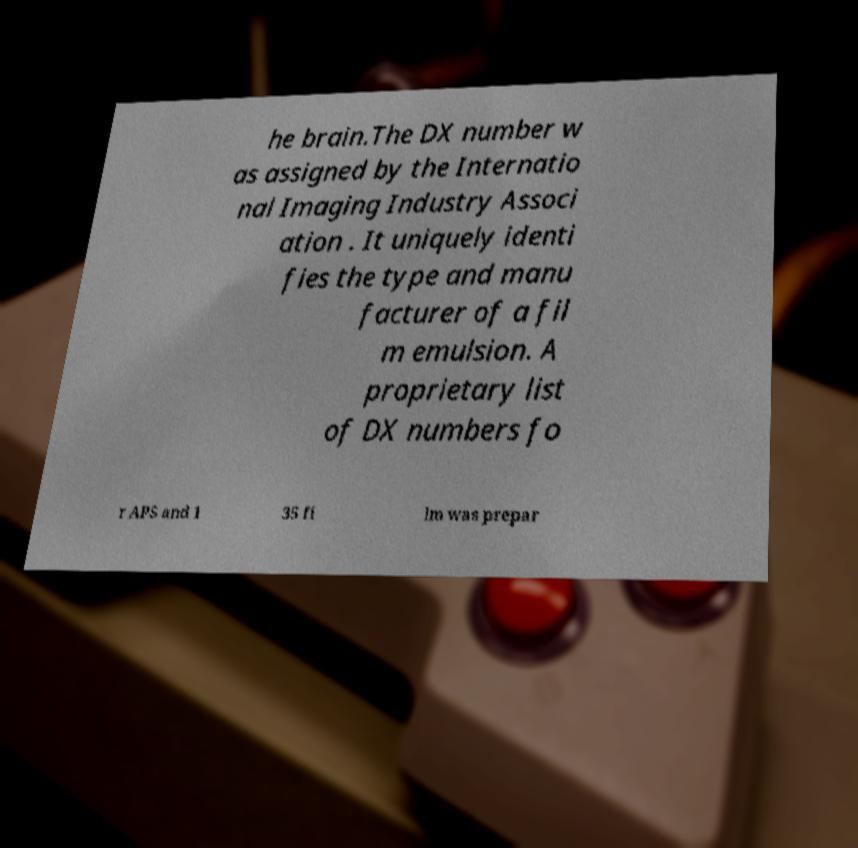Can you read and provide the text displayed in the image?This photo seems to have some interesting text. Can you extract and type it out for me? he brain.The DX number w as assigned by the Internatio nal Imaging Industry Associ ation . It uniquely identi fies the type and manu facturer of a fil m emulsion. A proprietary list of DX numbers fo r APS and 1 35 fi lm was prepar 